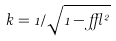<formula> <loc_0><loc_0><loc_500><loc_500>k = 1 / \sqrt { 1 - \epsilon ^ { 2 } }</formula> 